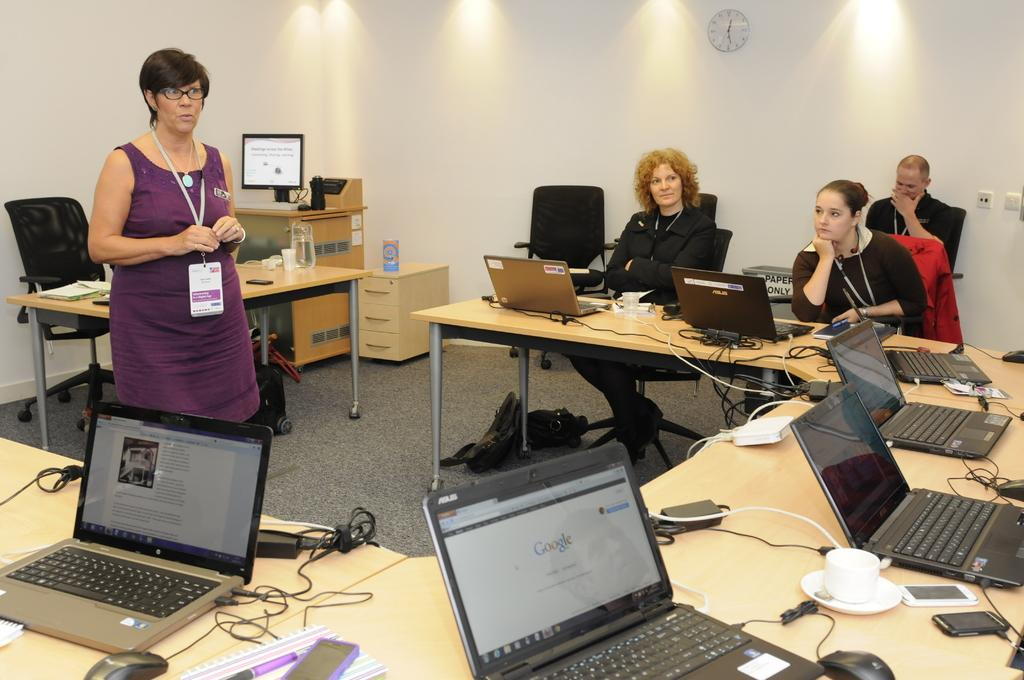<image>
Create a compact narrative representing the image presented. A lady speaking to a group of people with their laptops open, one is open to the Google homepage. 